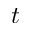Convert formula to latex. <formula><loc_0><loc_0><loc_500><loc_500>t</formula> 